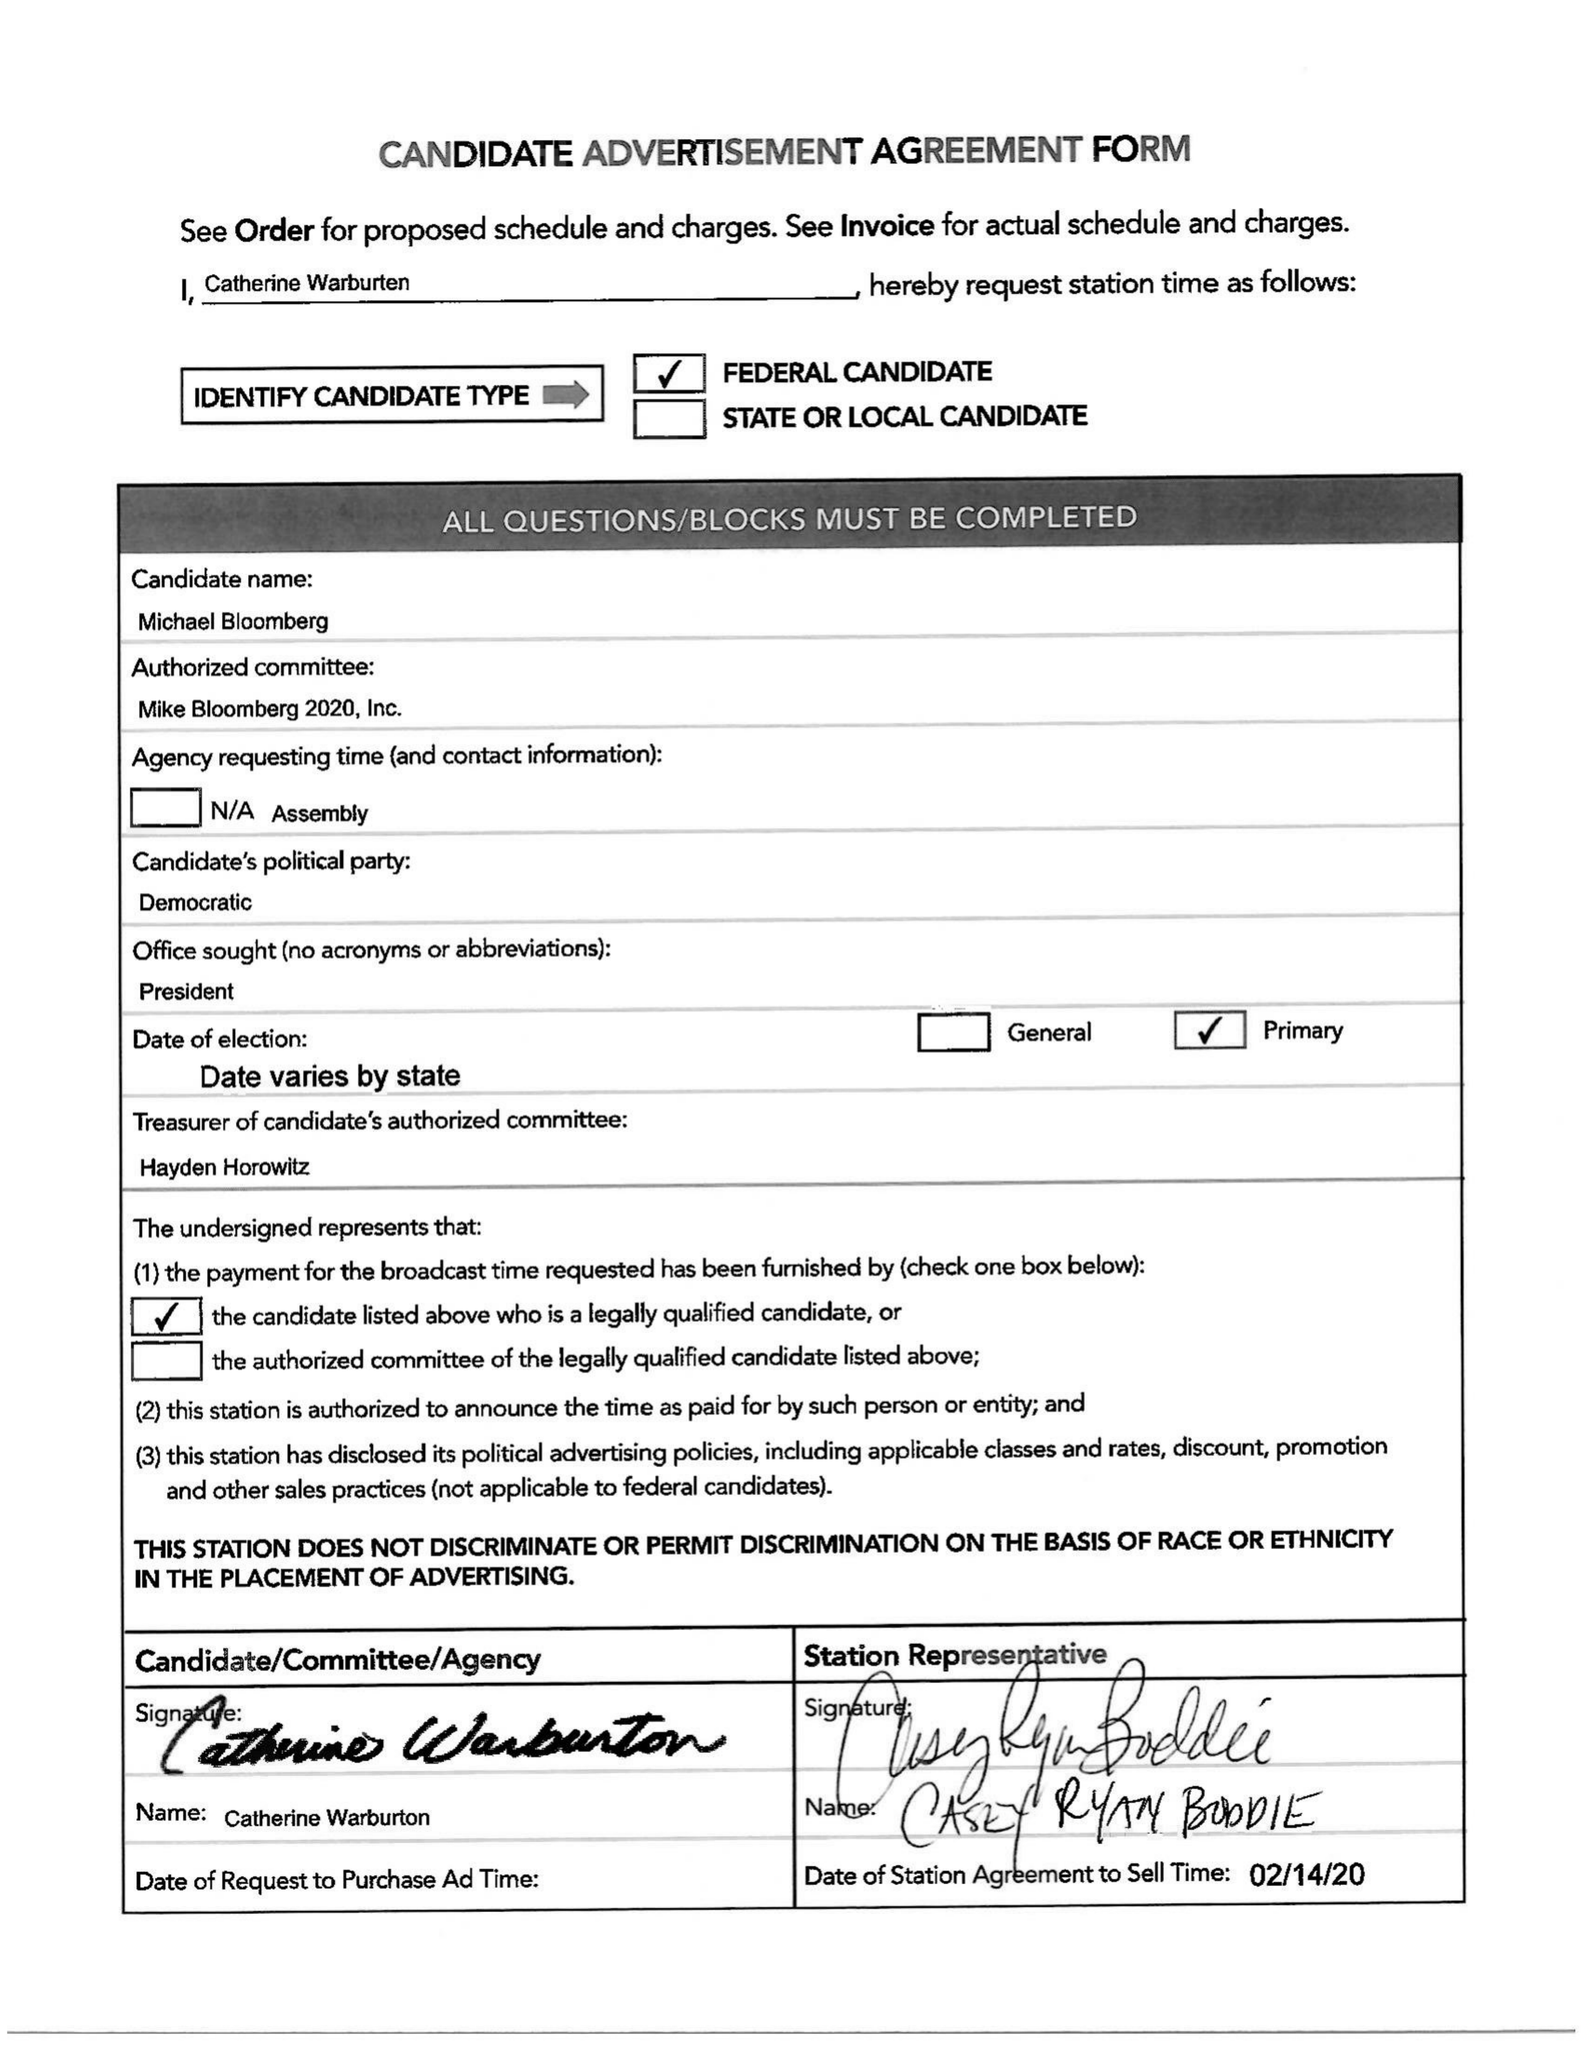What is the value for the flight_from?
Answer the question using a single word or phrase. 02/15/20 